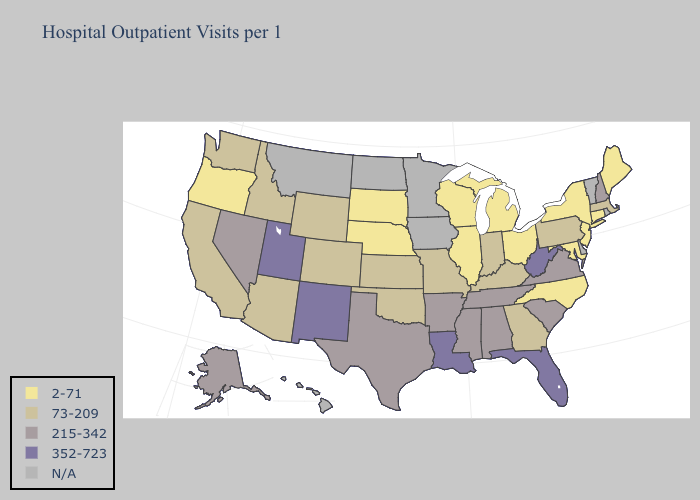What is the value of Connecticut?
Keep it brief. 2-71. Does Louisiana have the highest value in the South?
Concise answer only. Yes. Does New York have the lowest value in the Northeast?
Quick response, please. Yes. Does Oregon have the lowest value in the West?
Concise answer only. Yes. Name the states that have a value in the range 2-71?
Answer briefly. Connecticut, Illinois, Maine, Maryland, Michigan, Nebraska, New Jersey, New York, North Carolina, Ohio, Oregon, South Dakota, Wisconsin. Does the map have missing data?
Be succinct. Yes. Which states have the lowest value in the USA?
Keep it brief. Connecticut, Illinois, Maine, Maryland, Michigan, Nebraska, New Jersey, New York, North Carolina, Ohio, Oregon, South Dakota, Wisconsin. Which states have the highest value in the USA?
Answer briefly. Florida, Louisiana, New Mexico, Utah, West Virginia. Which states have the lowest value in the USA?
Concise answer only. Connecticut, Illinois, Maine, Maryland, Michigan, Nebraska, New Jersey, New York, North Carolina, Ohio, Oregon, South Dakota, Wisconsin. What is the value of Rhode Island?
Write a very short answer. N/A. Does Utah have the highest value in the West?
Quick response, please. Yes. Does the map have missing data?
Concise answer only. Yes. What is the highest value in the South ?
Write a very short answer. 352-723. Name the states that have a value in the range 73-209?
Short answer required. Arizona, California, Colorado, Georgia, Idaho, Indiana, Kansas, Kentucky, Massachusetts, Missouri, Oklahoma, Pennsylvania, Washington, Wyoming. 